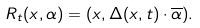<formula> <loc_0><loc_0><loc_500><loc_500>R _ { t } ( x , \alpha ) = ( x , \Delta ( x , t ) \cdot \overline { \alpha } ) .</formula> 